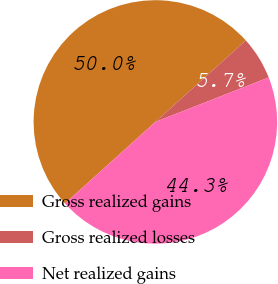<chart> <loc_0><loc_0><loc_500><loc_500><pie_chart><fcel>Gross realized gains<fcel>Gross realized losses<fcel>Net realized gains<nl><fcel>50.0%<fcel>5.73%<fcel>44.27%<nl></chart> 